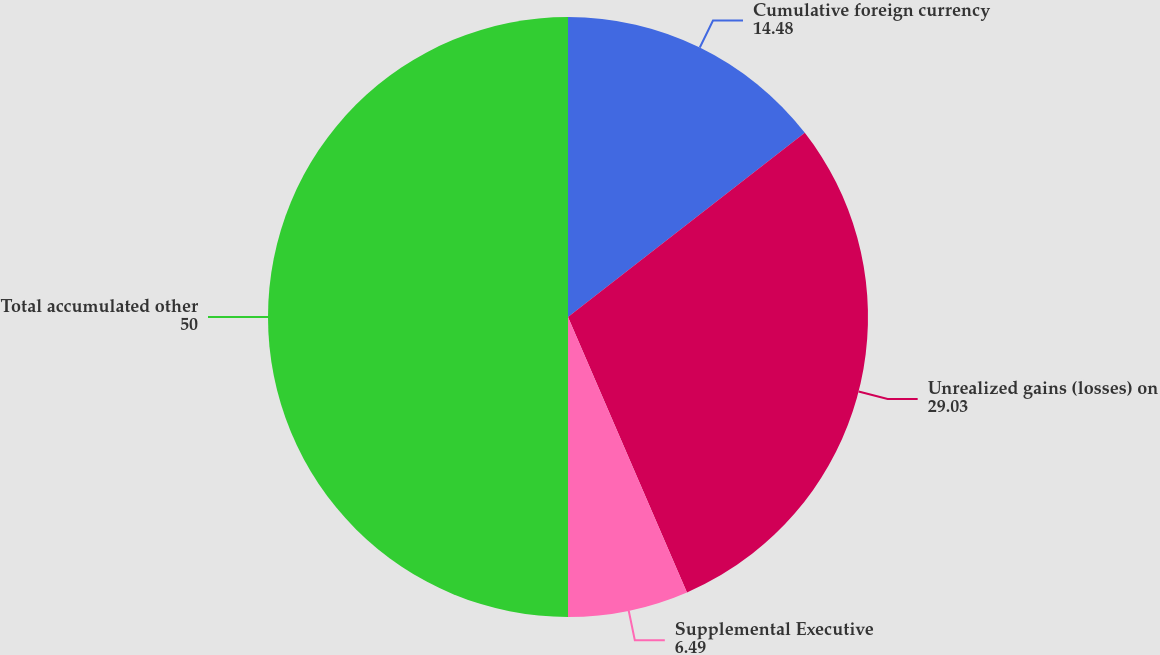Convert chart to OTSL. <chart><loc_0><loc_0><loc_500><loc_500><pie_chart><fcel>Cumulative foreign currency<fcel>Unrealized gains (losses) on<fcel>Supplemental Executive<fcel>Total accumulated other<nl><fcel>14.48%<fcel>29.03%<fcel>6.49%<fcel>50.0%<nl></chart> 